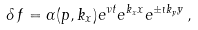Convert formula to latex. <formula><loc_0><loc_0><loc_500><loc_500>\delta \, f = \alpha ( p , k _ { x } ) e ^ { \nu t } e ^ { k _ { x } x } e ^ { \pm \imath k _ { y } y } \, ,</formula> 